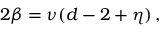Convert formula to latex. <formula><loc_0><loc_0><loc_500><loc_500>2 \beta = \nu ( d - 2 + \eta ) \, ,</formula> 